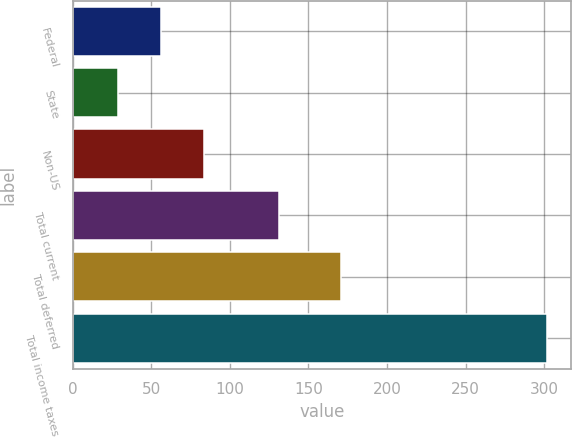Convert chart. <chart><loc_0><loc_0><loc_500><loc_500><bar_chart><fcel>Federal<fcel>State<fcel>Non-US<fcel>Total current<fcel>Total deferred<fcel>Total income taxes<nl><fcel>56.3<fcel>29<fcel>83.6<fcel>131<fcel>171<fcel>302<nl></chart> 